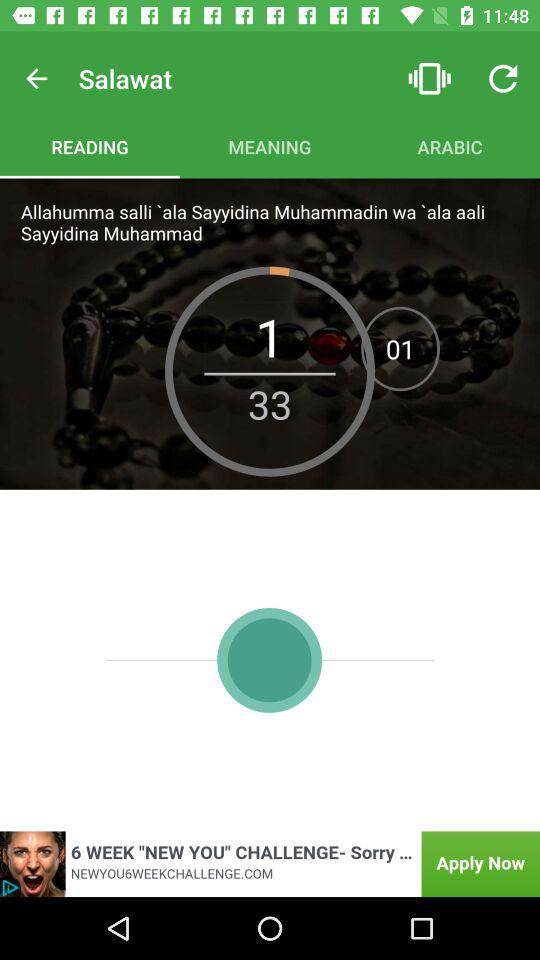How many items are in "ARABIC"?
When the provided information is insufficient, respond with <no answer>. <no answer> 